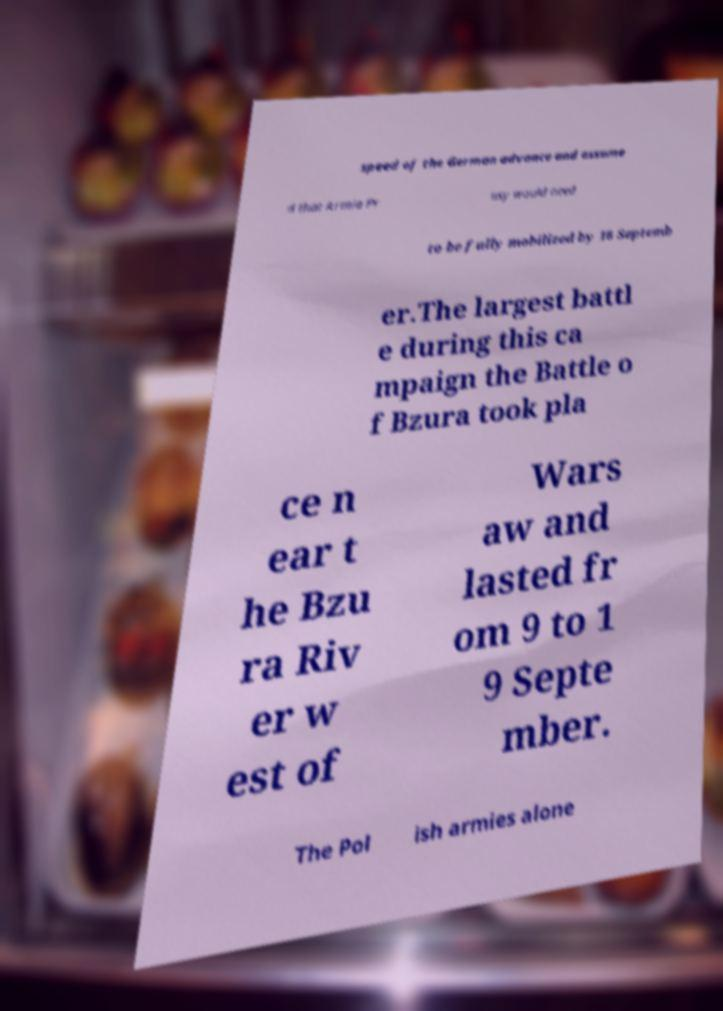Can you accurately transcribe the text from the provided image for me? speed of the German advance and assume d that Armia Pr usy would need to be fully mobilized by 16 Septemb er.The largest battl e during this ca mpaign the Battle o f Bzura took pla ce n ear t he Bzu ra Riv er w est of Wars aw and lasted fr om 9 to 1 9 Septe mber. The Pol ish armies alone 